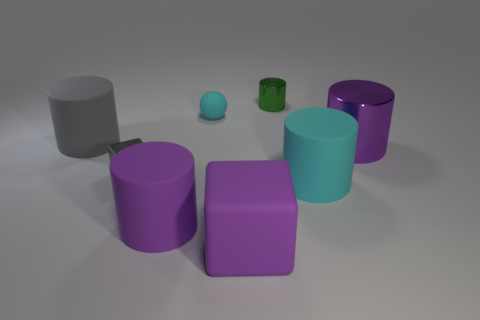Subtract all large purple cylinders. How many cylinders are left? 3 Add 2 tiny purple matte objects. How many objects exist? 10 Subtract all green cylinders. How many cylinders are left? 4 Subtract all cubes. How many objects are left? 6 Subtract 1 blocks. How many blocks are left? 1 Add 6 tiny shiny cylinders. How many tiny shiny cylinders are left? 7 Add 5 big red rubber objects. How many big red rubber objects exist? 5 Subtract 0 green balls. How many objects are left? 8 Subtract all brown cubes. Subtract all cyan spheres. How many cubes are left? 2 Subtract all brown blocks. How many brown cylinders are left? 0 